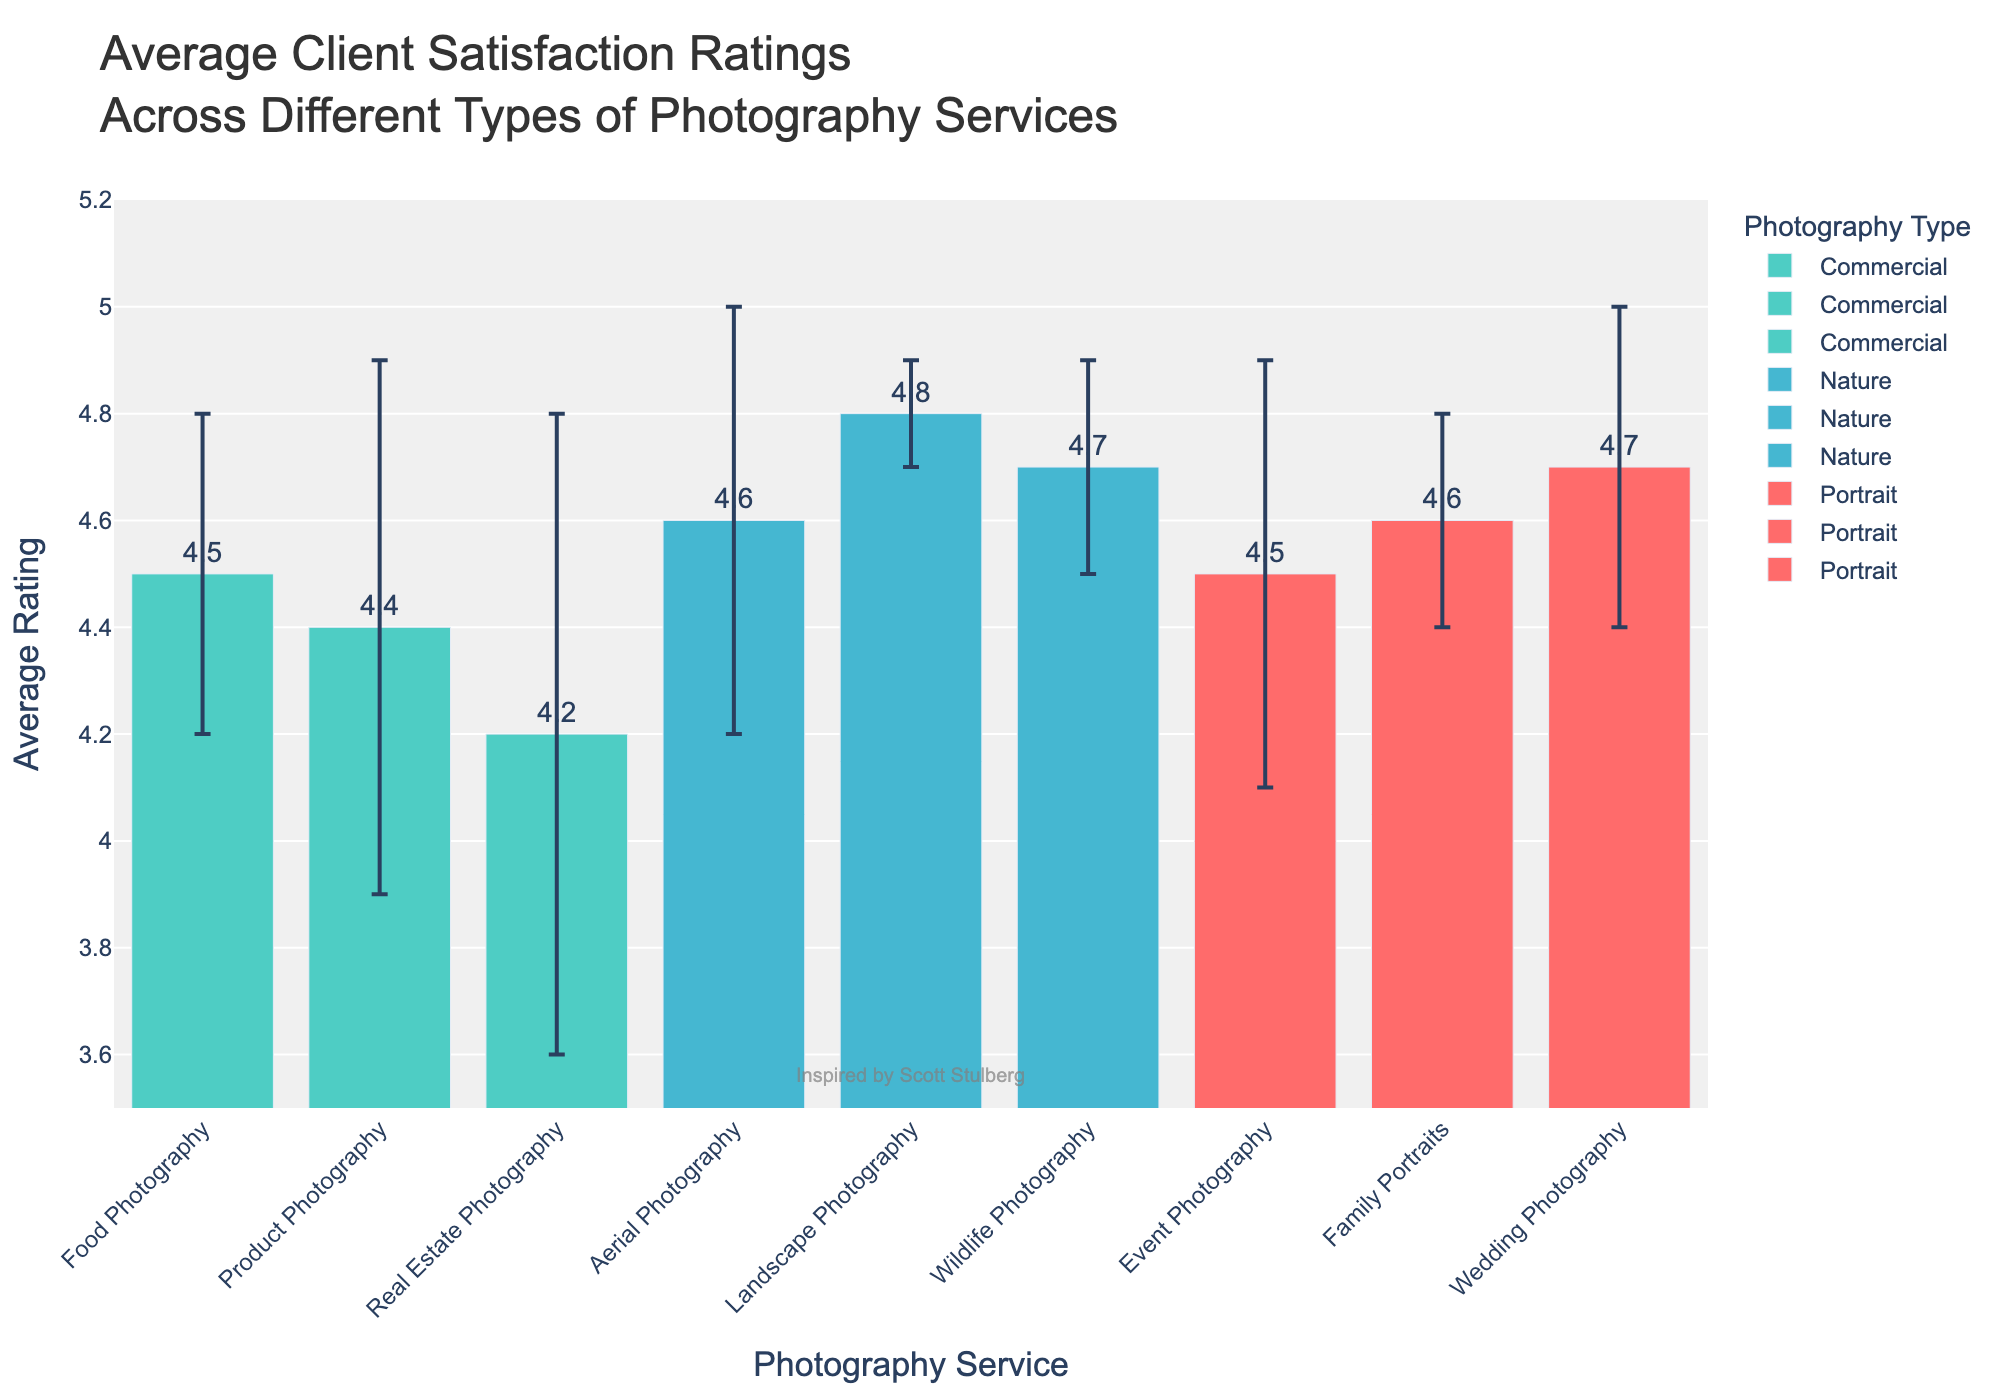What's the title of the chart? The title is at the top of the chart and clearly describes the content.
Answer: Average Client Satisfaction Ratings Across Different Types of Photography Services What is the average rating for Wedding Photography? The average rating for Wedding Photography can be directly read from the bar height with the labeled text.
Answer: 4.7 Which type of photography service has the highest average rating? By comparing all the bars, the highest bar is for Landscape Photography in the Nature category.
Answer: Landscape Photography How does the average rating of Real Estate Photography compare to Product Photography? The bar for Real Estate Photography is shorter than that for Product Photography.
Answer: Real Estate Photography has a lower average rating What's the average rating for Portrait-type services? Sum the average ratings of Wedding Photography, Event Photography, and Family Portraits and divide by 3 (4.7 + 4.5 + 4.6)/3.
Answer: 4.6 What are the colors used to represent different types of photography services? The colors of the bars indicate the type of photography, identified with the help of the legend.
Answer: Portrait: Red, Commercial: Teal, Nature: Light Blue Which service in the Commercial type has the highest standard deviation in ratings? The length of the error bars represents the standard deviation; Real Estate Photography has the longest error bar among Commercial services.
Answer: Real Estate Photography What is the difference between the highest and lowest average ratings in Nature-type services? Subtract the average rating of the lowest from the highest in the Nature category: 4.8 - 4.6.
Answer: 0.2 What's the combined average rating for all Nature-type services? Add the ratings of Landscape, Wildlife, and Aerial Photography, then divide by 3 (4.8 + 4.7 + 4.6)/3.
Answer: 4.7 What is the range of average ratings displayed on the y-axis? The y-axis range is determined by the scale visible from the bottom to the top of the chart's y-axis.
Answer: 3.5 to 5.2 